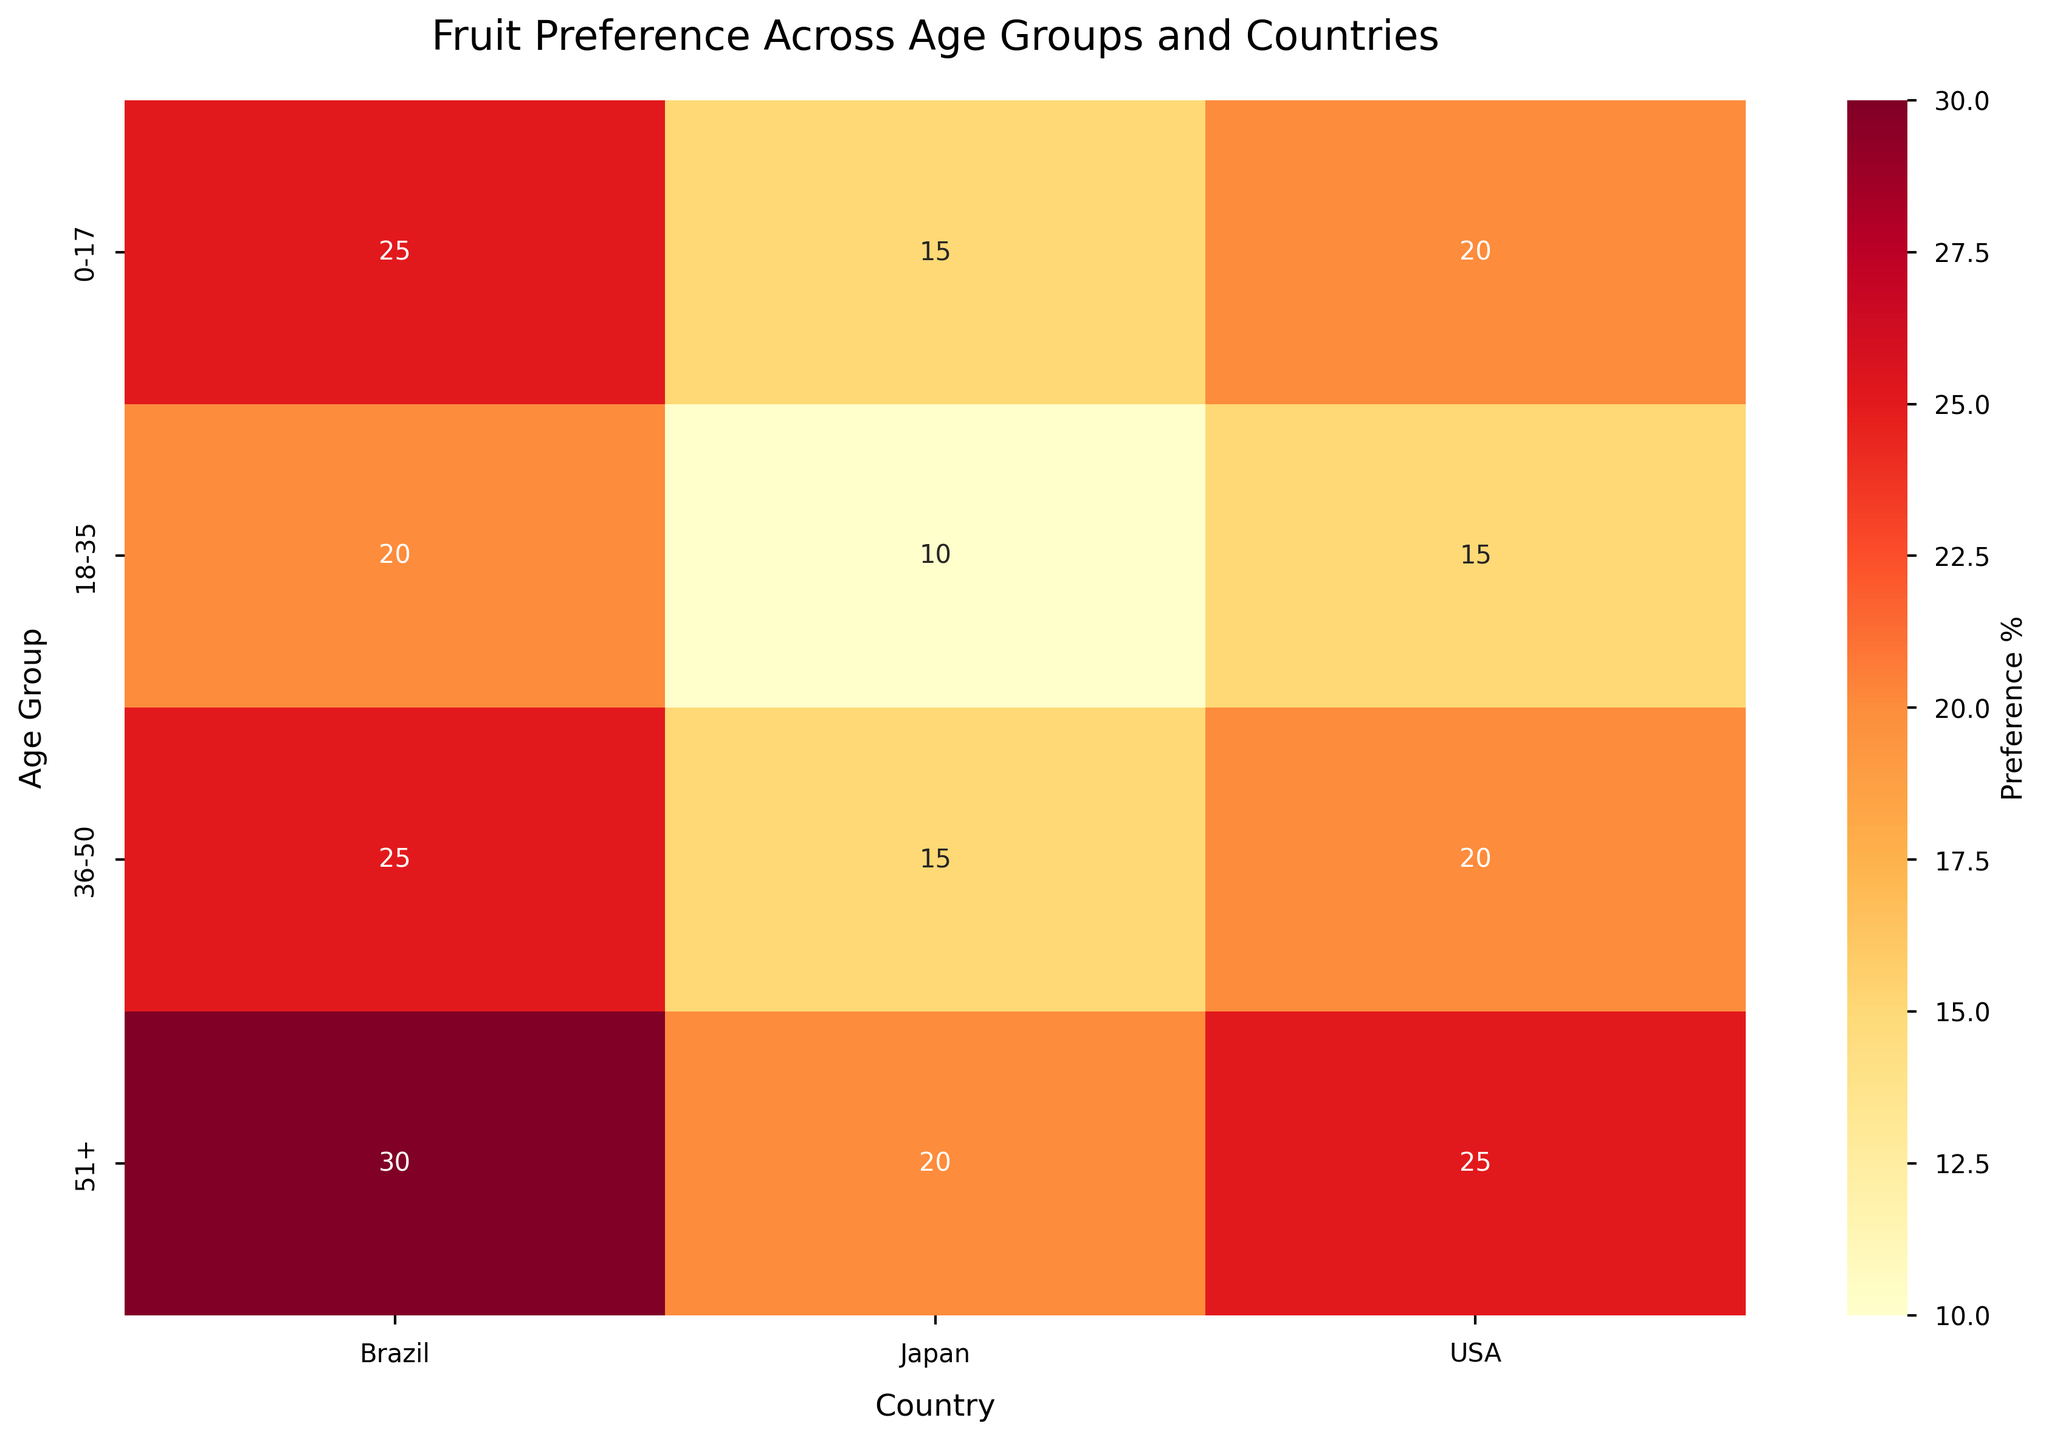What's the title of the heatmap? Look at the top of the figure where the title is usually located. It reads 'Fruit Preference Across Age Groups and Countries'.
Answer: Fruit Preference Across Age Groups and Countries Which country shows the highest fruit preference for the 0-17 age group? For the 0-17 age group, compare the values in the cells under the 'Fruits' column for the USA, Brazil, and Japan. The values are 20 for USA, 25 for Brazil, and 15 for Japan. Brazil has the highest value.
Answer: Brazil What is the average fruit preference percentage across all age groups in Brazil? Find the values for all age groups in Brazil (25 for 0-17, 20 for 18-35, 25 for 36-50, 30 for 51+), sum them (25+20+25+30=100) and divide by the number of age groups (4): 100/4 = 25.
Answer: 25 Is the fruit preference for the 51+ age group in Japan higher than in the USA? Compare the values for the fruit preference in the 51+ age group between Japan and the USA. Japan's value is 20 and the USA's value is 25.
Answer: No Which age group in Japan shows the highest preference for fruits? Compare all the values under Japan for different age groups (0-17 has 15, 18-35 has 10, 36-50 has 15, and 51+ has 20). The highest value is 20 for the 51+ age group.
Answer: 51+ How does the fruit preference change from the 0-17 to the 18-35 age group in the USA? Compare the values for the age groups 0-17 and 18-35 in the USA (20 and 15 respectively). There is a decrease of 5 percentage points.
Answer: Decreases by 5 What is the total fruit preference percentage for the 36-50 age group across all countries? Sum the fruit preferences for the 36-50 age group in all countries (USA has 20, Brazil has 25, Japan has 15): 20+25+15 = 60.
Answer: 60 Do more countries show a higher fruit preference for the 51+ age group or the 0-17 age group? Compare the number of countries with higher values for the 51+ age group (USA-25, Brazil-30, Japan-20) with those for the 0-17 age group (USA-20, Brazil-25, Japan-15). The 51+ age group has higher preferences in 3 countries compared to 2 for the 0-17 group.
Answer: 51+ age group Which age group in Brazil shows equal fruit preference to the 36-50 age group in the USA? Find the fruit preference for the 36-50 age group in the USA which is 20. Now look for the age group in Brazil with the same value. The 18-35 age group in Brazil has a value of 20.
Answer: 18-35 What's the difference in fruit preference between the 18-35 and 51+ age groups in Japan? Subtract the fruit preference percentage of the 18-35 age group (10) from that of the 51+ age group (20) in Japan: 20 - 10 = 10.
Answer: 10 